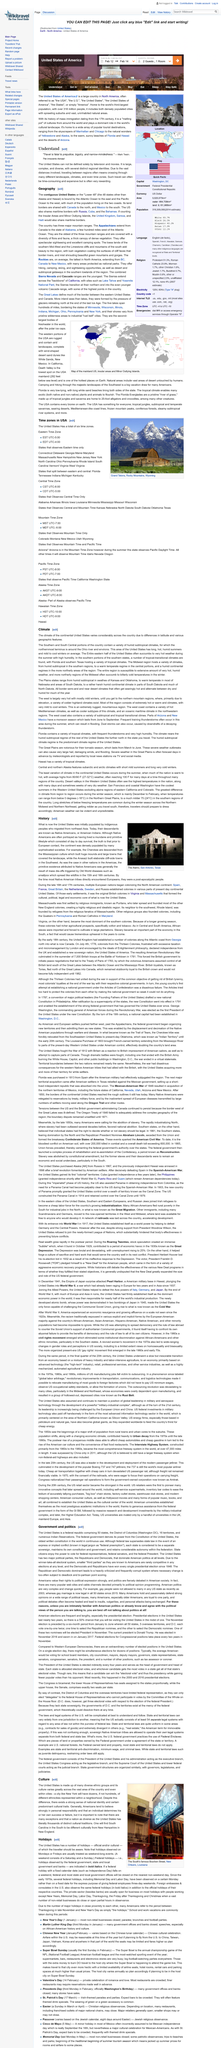List a handful of essential elements in this visual. Mass immigration to the United States began in the 17th century. The climate of the United States varies significantly due to differences in latitude and the presence of various geographic features. The population of the United States is 318 million people, making it the third largest country in the world in terms of population. The Pacific Ocean lies to the west of the United States. The state of Maryland observes Eastern time only, as it is declared. 